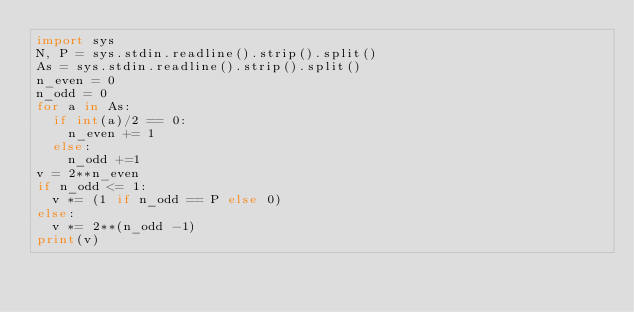Convert code to text. <code><loc_0><loc_0><loc_500><loc_500><_Python_>import sys
N, P = sys.stdin.readline().strip().split()
As = sys.stdin.readline().strip().split()
n_even = 0
n_odd = 0
for a in As:
  if int(a)/2 == 0:
    n_even += 1
  else:
    n_odd +=1
v = 2**n_even
if n_odd <= 1:
  v *= (1 if n_odd == P else 0)
else:
  v *= 2**(n_odd -1)
print(v)</code> 